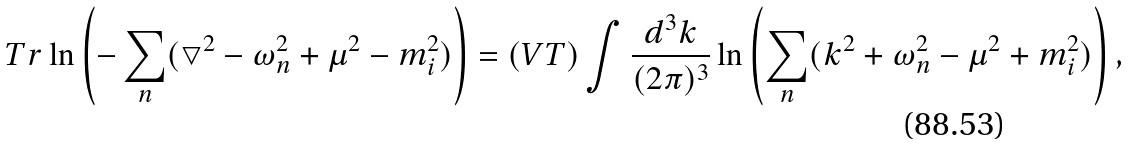<formula> <loc_0><loc_0><loc_500><loc_500>T r \ln \left ( - \sum _ { n } ( \bigtriangledown ^ { 2 } - \omega _ { n } ^ { 2 } + \mu ^ { 2 } - m _ { i } ^ { 2 } ) \right ) = ( V T ) \int \frac { d ^ { 3 } { k } } { ( 2 \pi ) ^ { 3 } } \ln \left ( \sum _ { n } ( { k } ^ { 2 } + \omega _ { n } ^ { 2 } - \mu ^ { 2 } + m _ { i } ^ { 2 } ) \right ) ,</formula> 